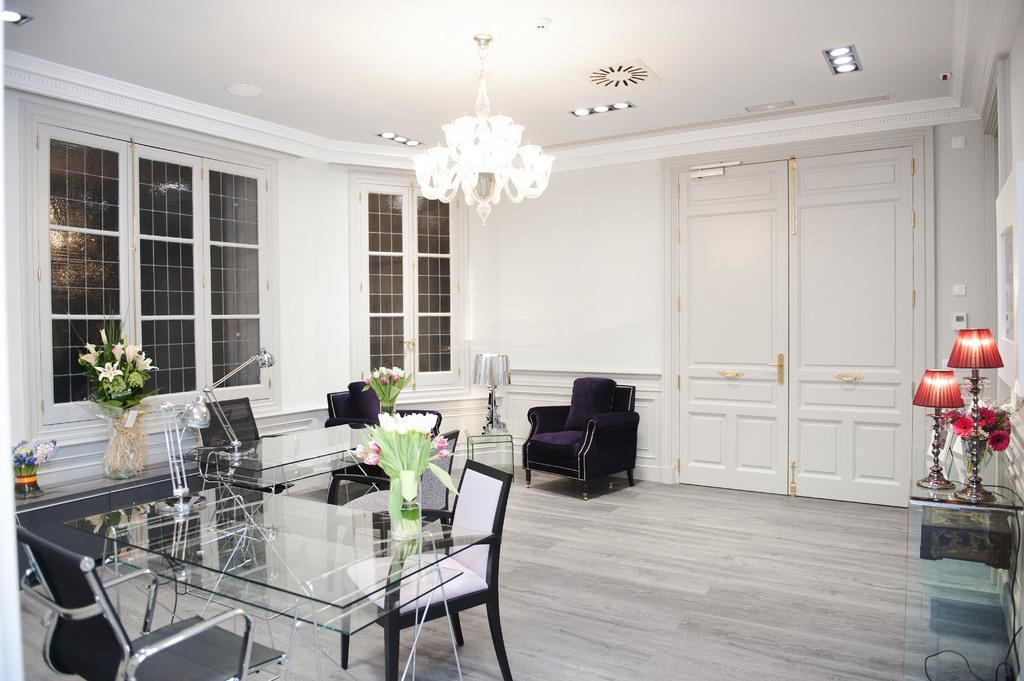Can you describe this image briefly? In this image, we can see dining table, chairs. Sofa in the middle. On the right side, there is a white color door, table lamps, wires and glass. We can see ash color floor. At the roof, we can see chandelier. The left side, we can see glass windows and flower vase. 